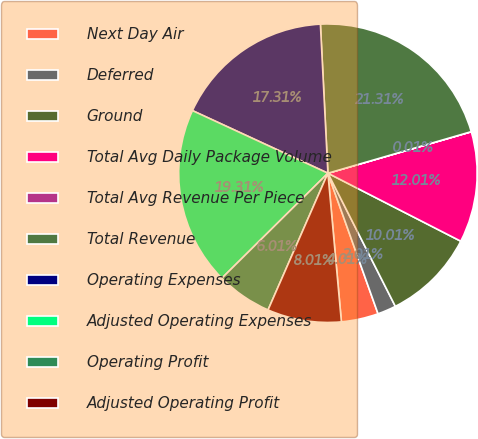Convert chart to OTSL. <chart><loc_0><loc_0><loc_500><loc_500><pie_chart><fcel>Next Day Air<fcel>Deferred<fcel>Ground<fcel>Total Avg Daily Package Volume<fcel>Total Avg Revenue Per Piece<fcel>Total Revenue<fcel>Operating Expenses<fcel>Adjusted Operating Expenses<fcel>Operating Profit<fcel>Adjusted Operating Profit<nl><fcel>4.01%<fcel>2.01%<fcel>10.01%<fcel>12.01%<fcel>0.01%<fcel>21.31%<fcel>17.31%<fcel>19.31%<fcel>6.01%<fcel>8.01%<nl></chart> 